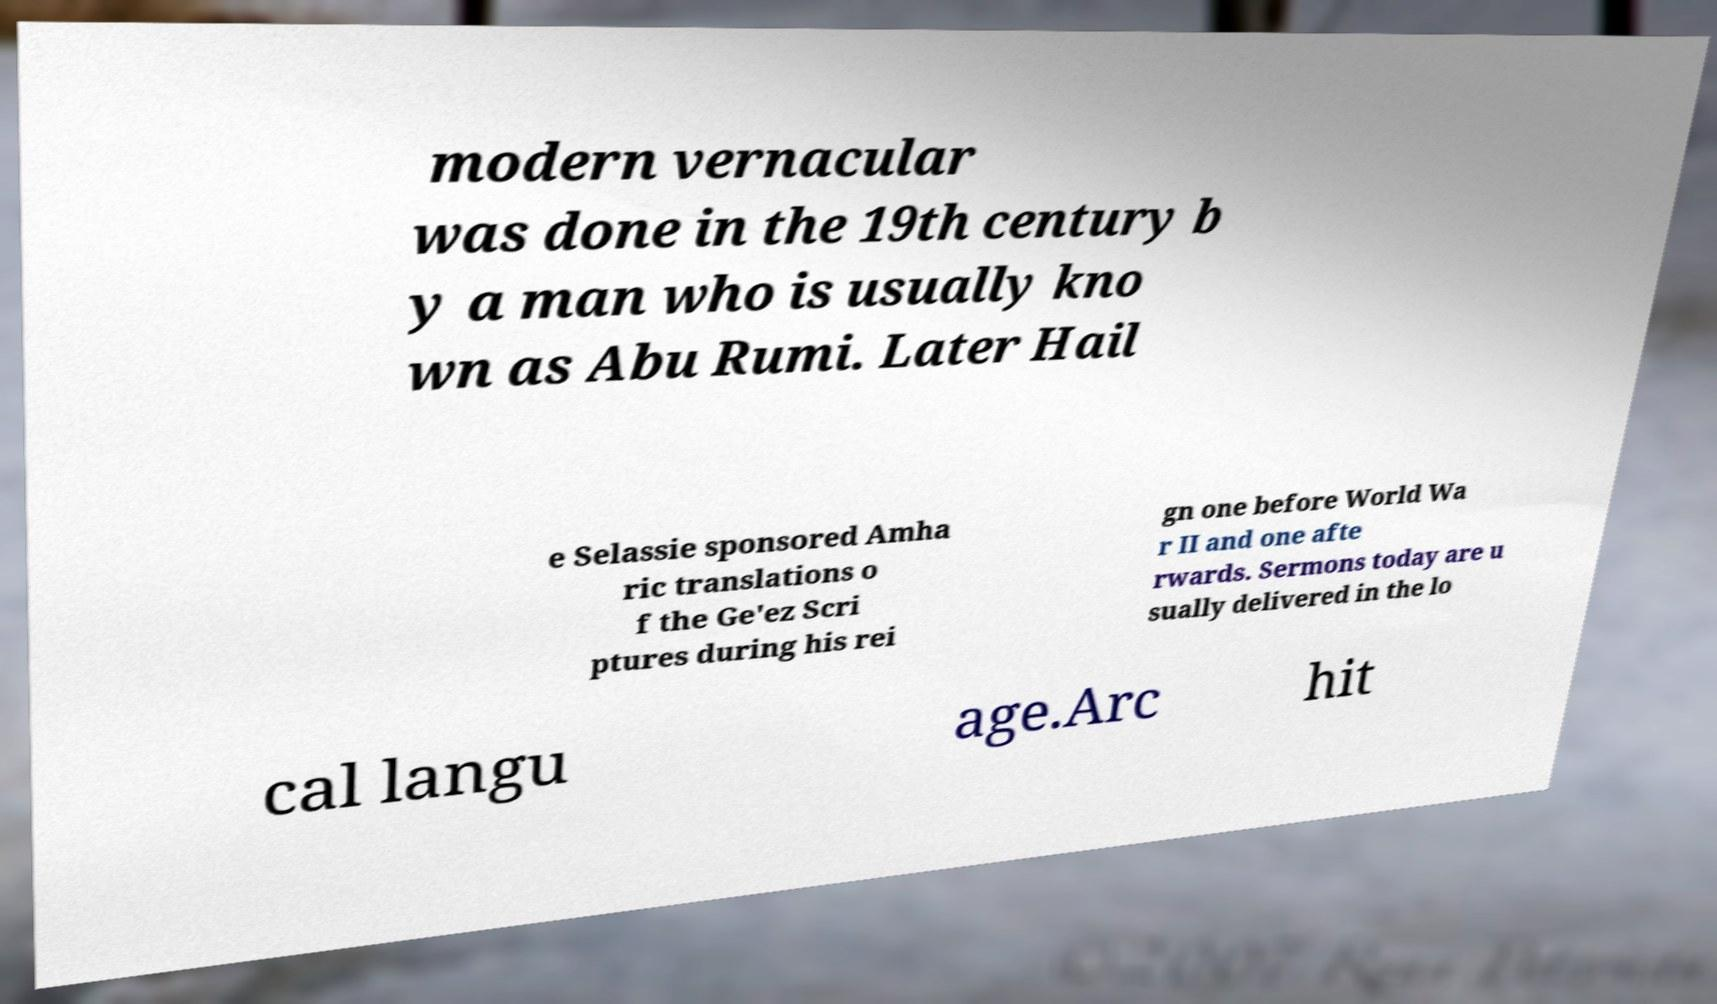Could you extract and type out the text from this image? modern vernacular was done in the 19th century b y a man who is usually kno wn as Abu Rumi. Later Hail e Selassie sponsored Amha ric translations o f the Ge'ez Scri ptures during his rei gn one before World Wa r II and one afte rwards. Sermons today are u sually delivered in the lo cal langu age.Arc hit 